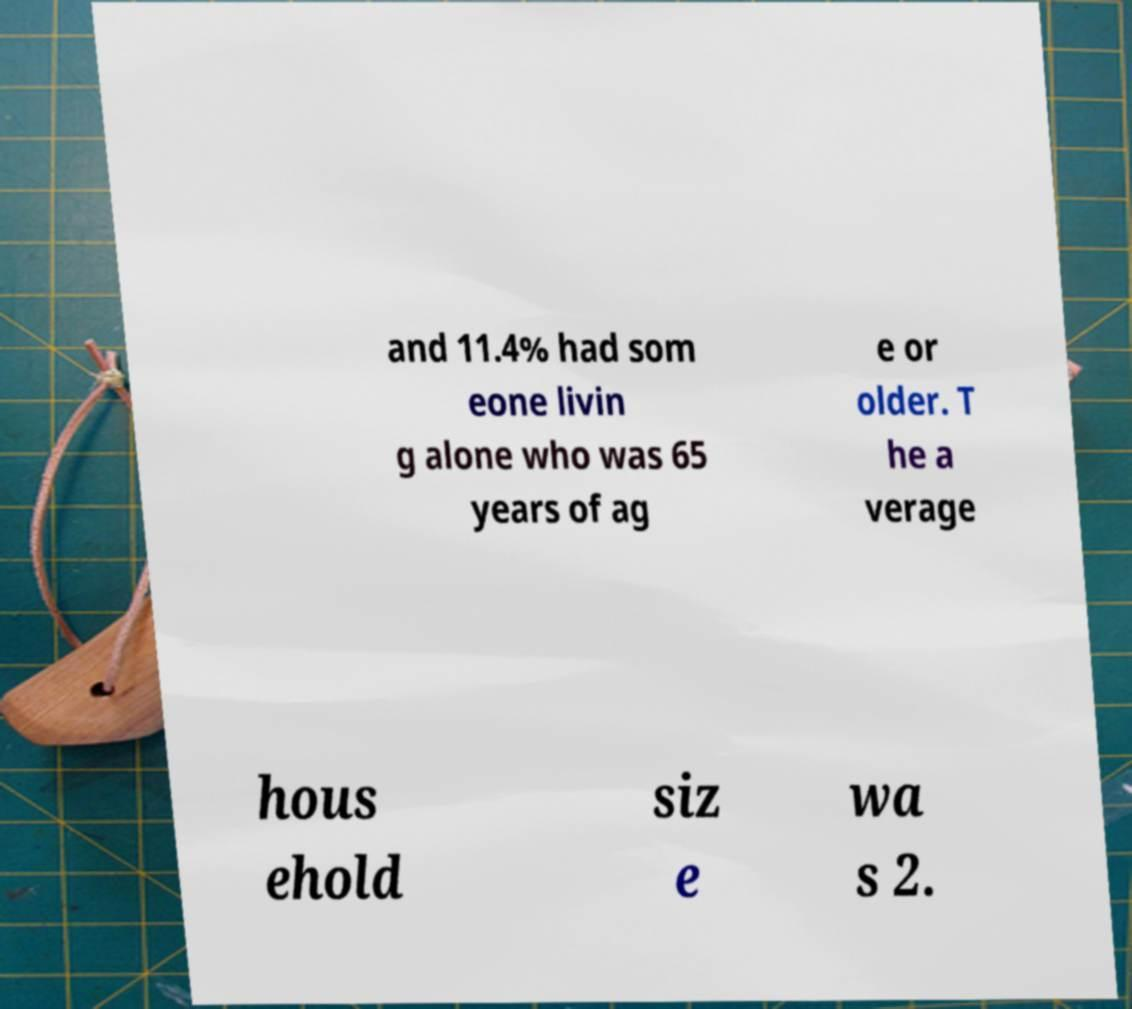Please identify and transcribe the text found in this image. and 11.4% had som eone livin g alone who was 65 years of ag e or older. T he a verage hous ehold siz e wa s 2. 